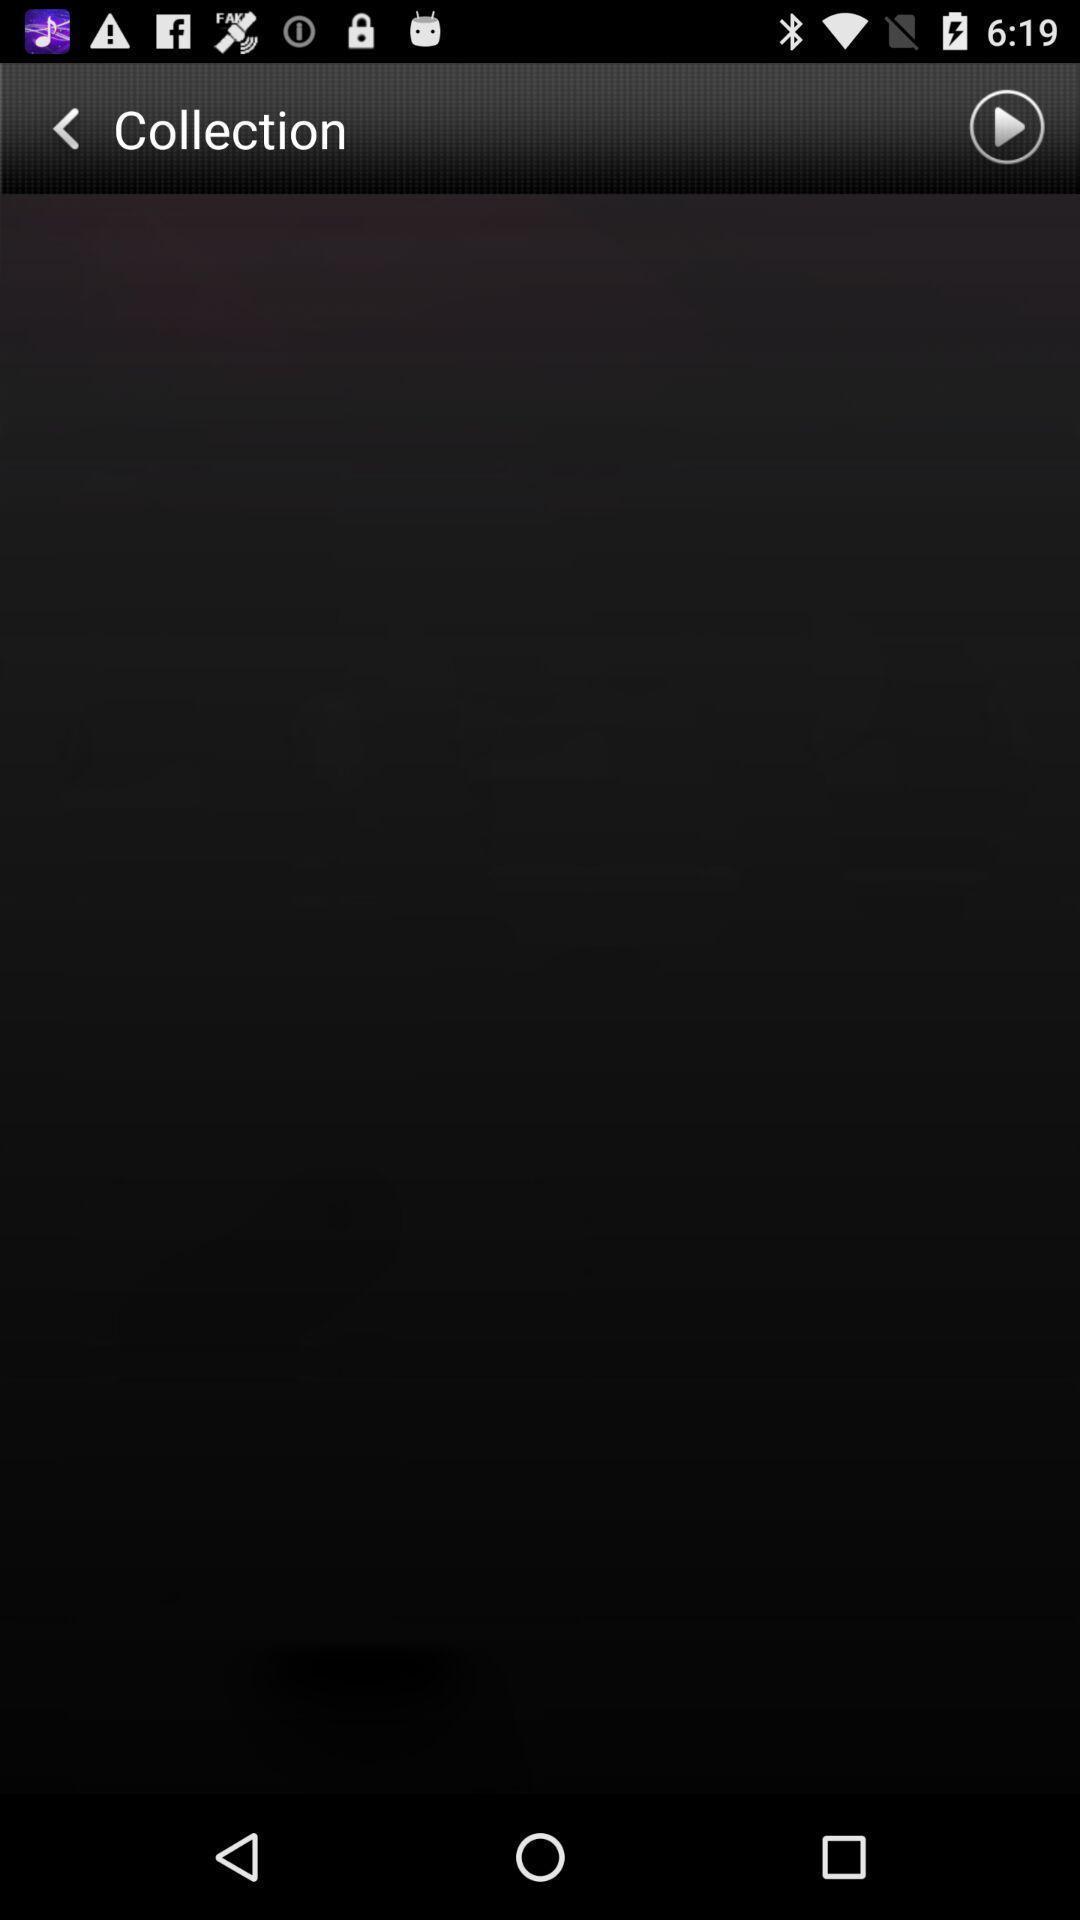Summarize the information in this screenshot. Screen shows collection option with blank page. 